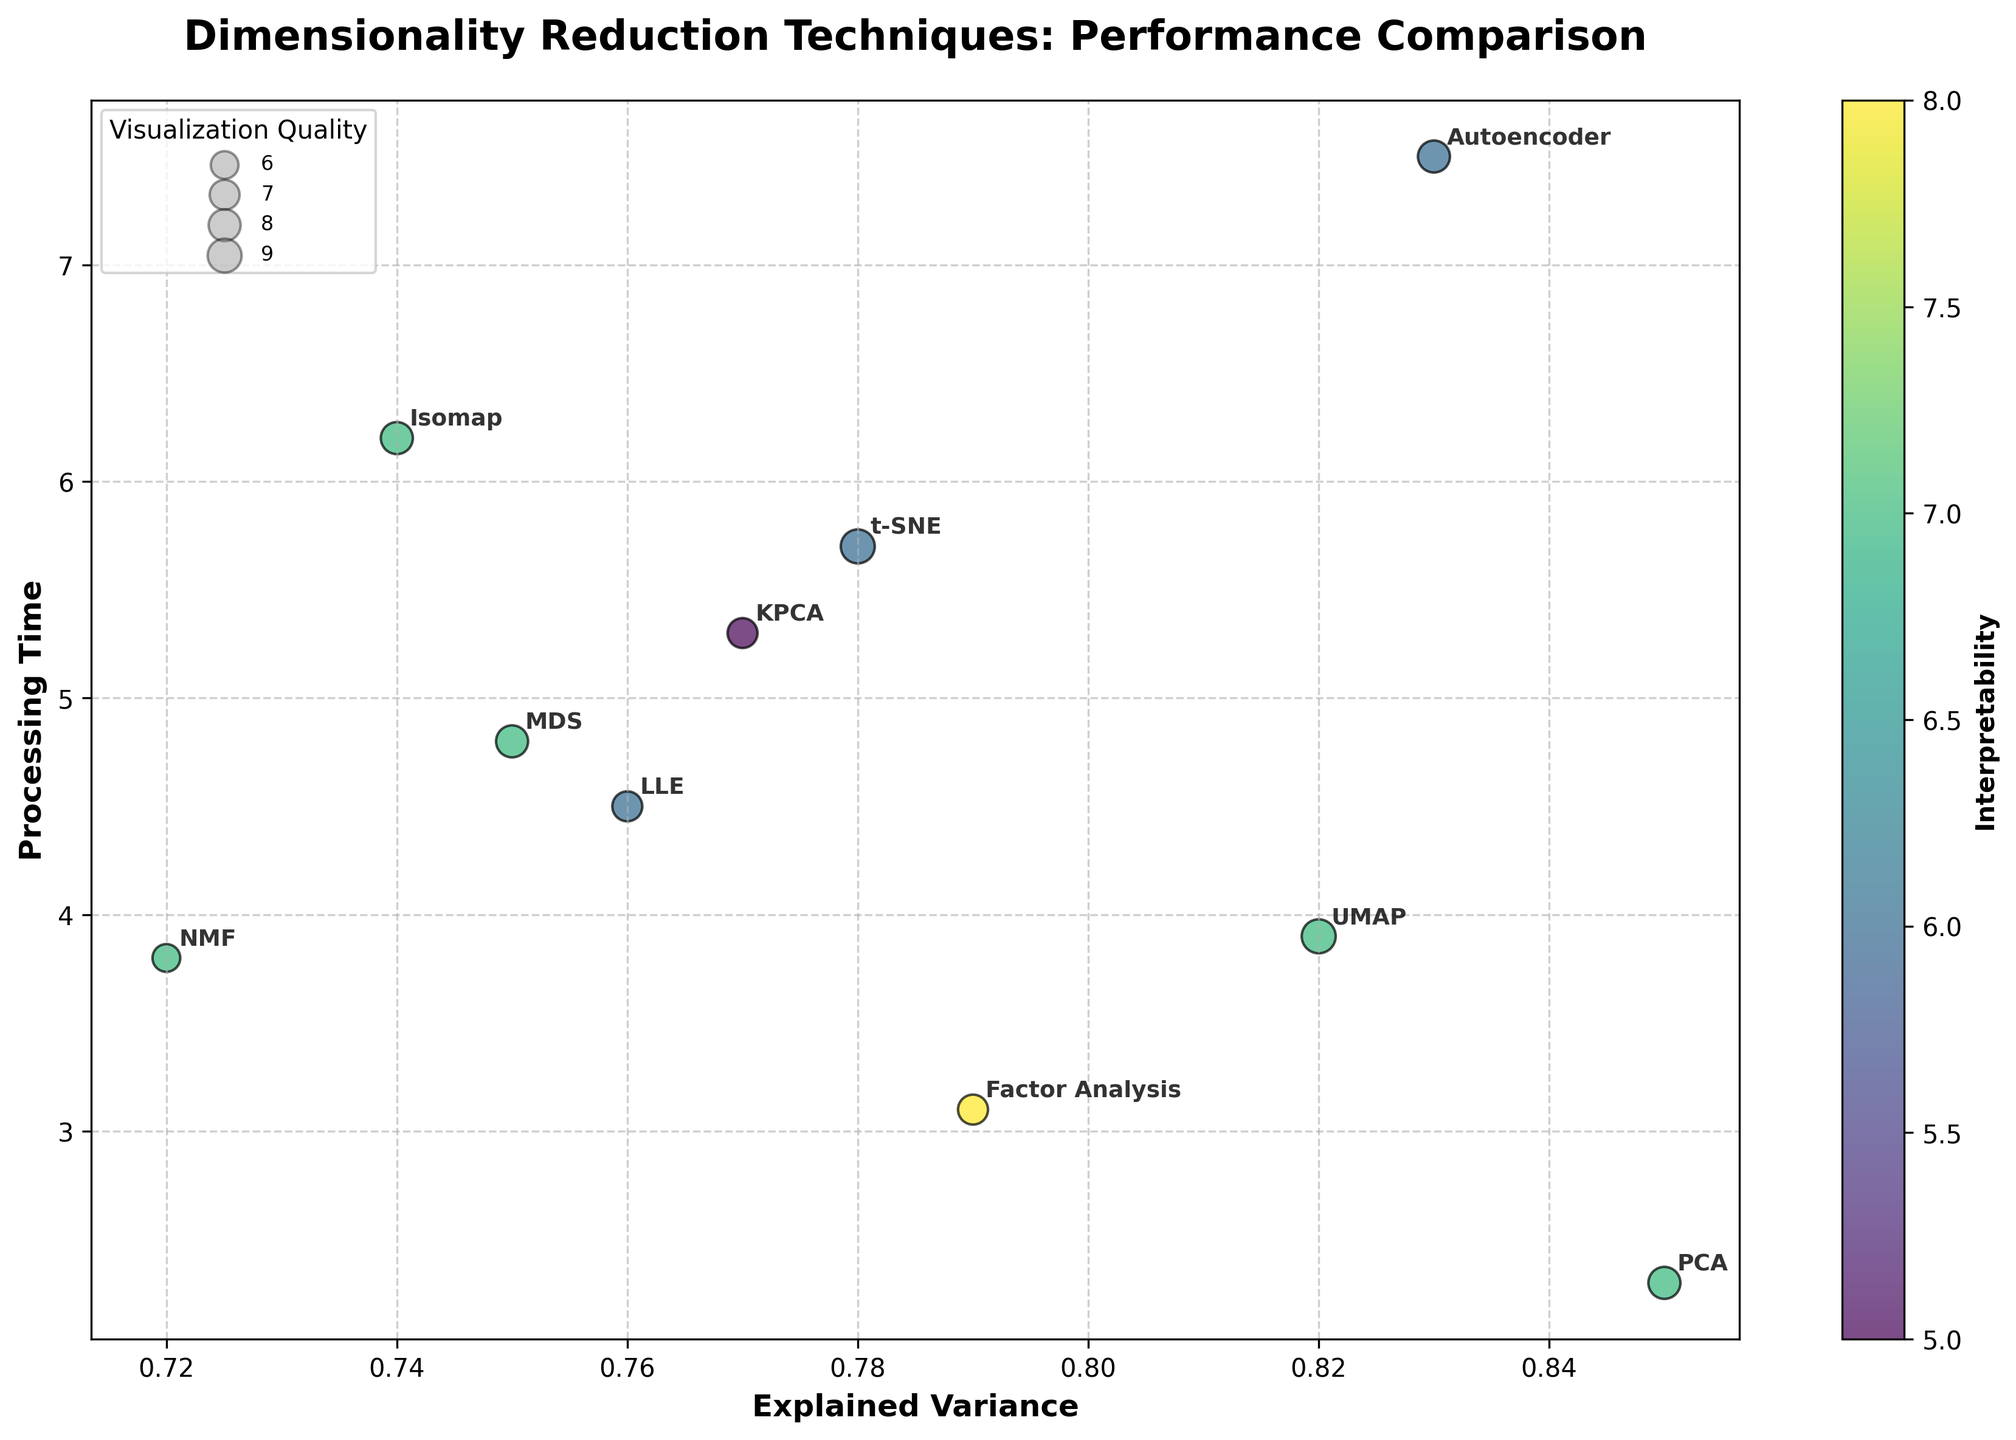What is the dimensionality reduction technique with the highest explained variance? The scatter plot shows the explained variance on the x-axis. The technique with the highest x-value is PCA at 0.85.
Answer: PCA Which technique has the longest processing time? The scatter plot shows the processing time on the y-axis. The technique with the highest y-value is Autoencoder at 7.5.
Answer: Autoencoder What is the relationship between processing time and explained variance for t-SNE? t-SNE has an explained variance of 0.78 and a processing time of 5.7, thus it has high variance explained but requires considerable processing time.
Answer: High explained variance, high processing time Which technique demonstrates the best balance between interpretability and visualization quality? From the color bar representing interpretability and bubble sizes indicating visualization quality, UMAP has high marks in both, with an interpretability score of 7 and a visualization quality of 9.
Answer: UMAP How does the interpretability of KPCA compare to LLE? KPCA has an interpretability score of 5, while LLE has a score of 6, making LLE slightly more interpretable.
Answer: LLE is more interpretable What is the processing time difference between PCA and NMF? PCA has a processing time of 2.3, and NMF has a processing time of 3.8. The difference is \(3.8 - 2.3 = 1.5\).
Answer: 1.5 Which technique has an explained variance closest to the overall average explained variance of all techniques? To find the closest value, we need to calculate the average explained variance. The average is \((0.85+0.78+0.82+0.76+0.74+0.79+0.72+0.83+0.77+0.75)/10 = 7.81/10 = 0.781\). The closest technique is t-SNE (0.78).
Answer: t-SNE What is the general trend between explained variance and processing time? By observing the scatter plot, there seems to be no clear linear relationship between explained variance and processing time, as high explained variance techniques like PCA and UMAP have both low and moderate processing times.
Answer: No clear trend Which technique appears to be the most scalable, having high explained variance and processing time below 5? PCA has high explained variance (0.85) and a low processing time (2.3), which suggests it is the most scalable.
Answer: PCA 